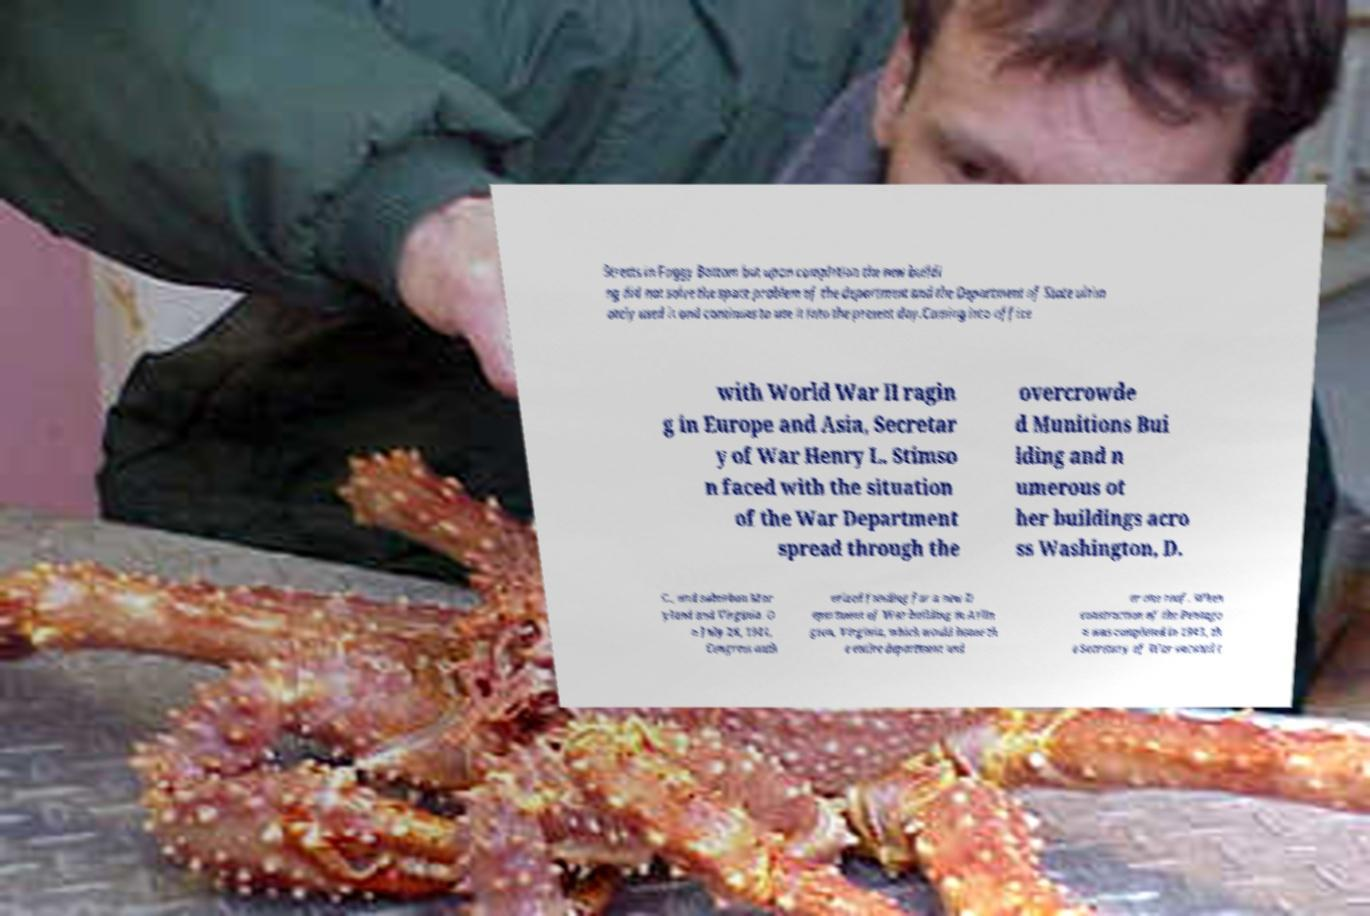Can you accurately transcribe the text from the provided image for me? Streets in Foggy Bottom but upon completion the new buildi ng did not solve the space problem of the department and the Department of State ultim ately used it and continues to use it into the present day.Coming into office with World War II ragin g in Europe and Asia, Secretar y of War Henry L. Stimso n faced with the situation of the War Department spread through the overcrowde d Munitions Bui lding and n umerous ot her buildings acro ss Washington, D. C., and suburban Mar yland and Virginia. O n July 28, 1941, Congress auth orized funding for a new D epartment of War building in Arlin gton, Virginia, which would house th e entire department und er one roof. When construction of the Pentago n was completed in 1943, th e Secretary of War vacated t 